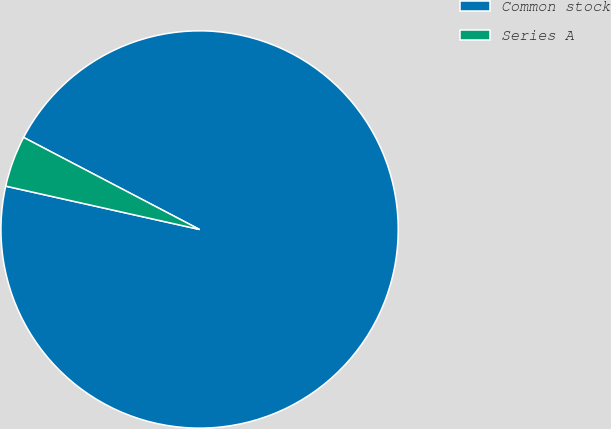Convert chart. <chart><loc_0><loc_0><loc_500><loc_500><pie_chart><fcel>Common stock<fcel>Series A<nl><fcel>95.83%<fcel>4.17%<nl></chart> 